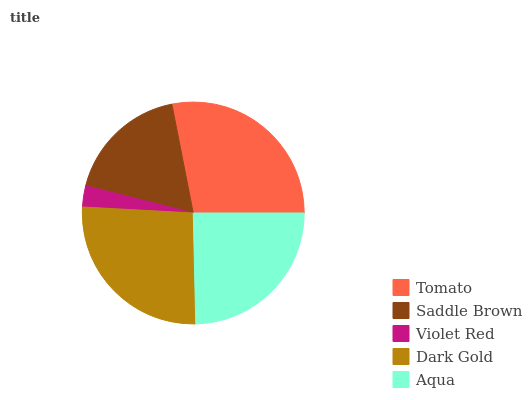Is Violet Red the minimum?
Answer yes or no. Yes. Is Tomato the maximum?
Answer yes or no. Yes. Is Saddle Brown the minimum?
Answer yes or no. No. Is Saddle Brown the maximum?
Answer yes or no. No. Is Tomato greater than Saddle Brown?
Answer yes or no. Yes. Is Saddle Brown less than Tomato?
Answer yes or no. Yes. Is Saddle Brown greater than Tomato?
Answer yes or no. No. Is Tomato less than Saddle Brown?
Answer yes or no. No. Is Aqua the high median?
Answer yes or no. Yes. Is Aqua the low median?
Answer yes or no. Yes. Is Saddle Brown the high median?
Answer yes or no. No. Is Tomato the low median?
Answer yes or no. No. 